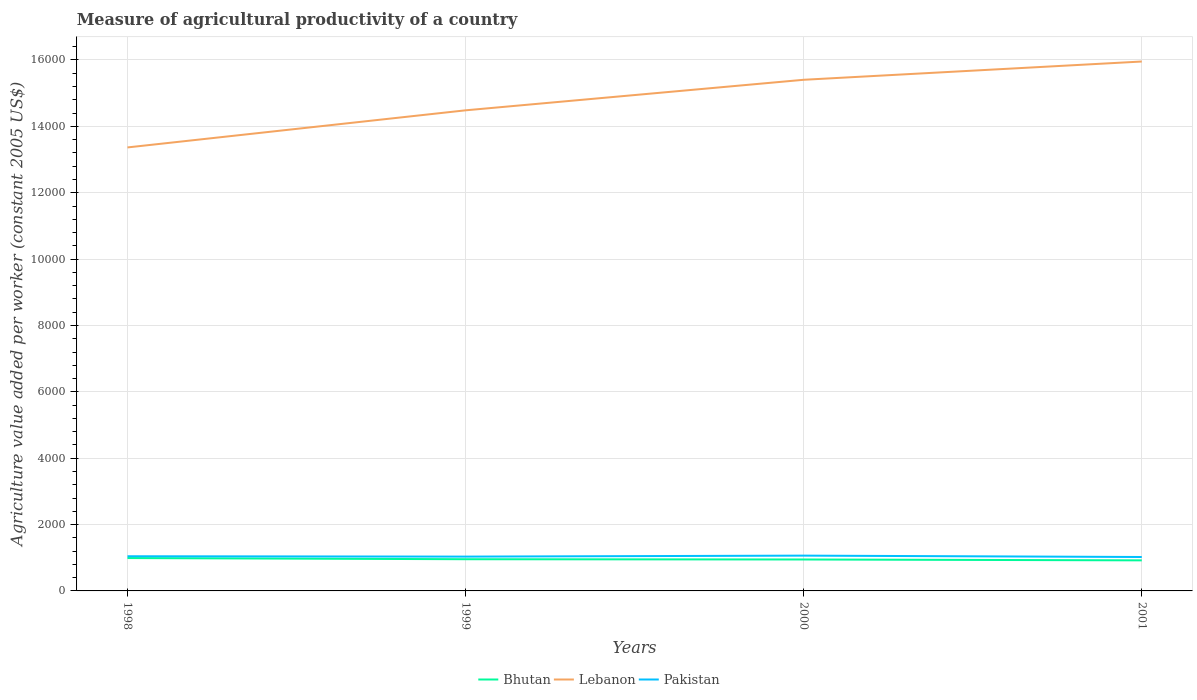How many different coloured lines are there?
Ensure brevity in your answer.  3. Does the line corresponding to Pakistan intersect with the line corresponding to Bhutan?
Offer a terse response. No. Is the number of lines equal to the number of legend labels?
Offer a terse response. Yes. Across all years, what is the maximum measure of agricultural productivity in Pakistan?
Make the answer very short. 1022.46. In which year was the measure of agricultural productivity in Pakistan maximum?
Keep it short and to the point. 2001. What is the total measure of agricultural productivity in Lebanon in the graph?
Give a very brief answer. -920.3. What is the difference between the highest and the second highest measure of agricultural productivity in Bhutan?
Make the answer very short. 69.25. How many lines are there?
Offer a very short reply. 3. How many legend labels are there?
Provide a short and direct response. 3. What is the title of the graph?
Offer a terse response. Measure of agricultural productivity of a country. What is the label or title of the Y-axis?
Offer a very short reply. Agriculture value added per worker (constant 2005 US$). What is the Agriculture value added per worker (constant 2005 US$) of Bhutan in 1998?
Your answer should be very brief. 990.49. What is the Agriculture value added per worker (constant 2005 US$) in Lebanon in 1998?
Offer a terse response. 1.34e+04. What is the Agriculture value added per worker (constant 2005 US$) of Pakistan in 1998?
Offer a very short reply. 1044.93. What is the Agriculture value added per worker (constant 2005 US$) of Bhutan in 1999?
Give a very brief answer. 955.44. What is the Agriculture value added per worker (constant 2005 US$) in Lebanon in 1999?
Keep it short and to the point. 1.45e+04. What is the Agriculture value added per worker (constant 2005 US$) in Pakistan in 1999?
Provide a succinct answer. 1034. What is the Agriculture value added per worker (constant 2005 US$) in Bhutan in 2000?
Keep it short and to the point. 947.3. What is the Agriculture value added per worker (constant 2005 US$) in Lebanon in 2000?
Your response must be concise. 1.54e+04. What is the Agriculture value added per worker (constant 2005 US$) of Pakistan in 2000?
Your response must be concise. 1063.71. What is the Agriculture value added per worker (constant 2005 US$) of Bhutan in 2001?
Provide a succinct answer. 921.23. What is the Agriculture value added per worker (constant 2005 US$) of Lebanon in 2001?
Your response must be concise. 1.60e+04. What is the Agriculture value added per worker (constant 2005 US$) in Pakistan in 2001?
Your answer should be compact. 1022.46. Across all years, what is the maximum Agriculture value added per worker (constant 2005 US$) in Bhutan?
Provide a succinct answer. 990.49. Across all years, what is the maximum Agriculture value added per worker (constant 2005 US$) of Lebanon?
Your answer should be very brief. 1.60e+04. Across all years, what is the maximum Agriculture value added per worker (constant 2005 US$) of Pakistan?
Your answer should be compact. 1063.71. Across all years, what is the minimum Agriculture value added per worker (constant 2005 US$) in Bhutan?
Ensure brevity in your answer.  921.23. Across all years, what is the minimum Agriculture value added per worker (constant 2005 US$) in Lebanon?
Your response must be concise. 1.34e+04. Across all years, what is the minimum Agriculture value added per worker (constant 2005 US$) of Pakistan?
Offer a terse response. 1022.46. What is the total Agriculture value added per worker (constant 2005 US$) in Bhutan in the graph?
Offer a very short reply. 3814.46. What is the total Agriculture value added per worker (constant 2005 US$) in Lebanon in the graph?
Your answer should be very brief. 5.92e+04. What is the total Agriculture value added per worker (constant 2005 US$) of Pakistan in the graph?
Your response must be concise. 4165.11. What is the difference between the Agriculture value added per worker (constant 2005 US$) in Bhutan in 1998 and that in 1999?
Your answer should be compact. 35.05. What is the difference between the Agriculture value added per worker (constant 2005 US$) of Lebanon in 1998 and that in 1999?
Give a very brief answer. -1118.39. What is the difference between the Agriculture value added per worker (constant 2005 US$) in Pakistan in 1998 and that in 1999?
Offer a very short reply. 10.93. What is the difference between the Agriculture value added per worker (constant 2005 US$) in Bhutan in 1998 and that in 2000?
Provide a succinct answer. 43.19. What is the difference between the Agriculture value added per worker (constant 2005 US$) of Lebanon in 1998 and that in 2000?
Give a very brief answer. -2038.69. What is the difference between the Agriculture value added per worker (constant 2005 US$) in Pakistan in 1998 and that in 2000?
Make the answer very short. -18.78. What is the difference between the Agriculture value added per worker (constant 2005 US$) in Bhutan in 1998 and that in 2001?
Ensure brevity in your answer.  69.25. What is the difference between the Agriculture value added per worker (constant 2005 US$) of Lebanon in 1998 and that in 2001?
Provide a succinct answer. -2589.12. What is the difference between the Agriculture value added per worker (constant 2005 US$) in Pakistan in 1998 and that in 2001?
Give a very brief answer. 22.47. What is the difference between the Agriculture value added per worker (constant 2005 US$) in Bhutan in 1999 and that in 2000?
Make the answer very short. 8.14. What is the difference between the Agriculture value added per worker (constant 2005 US$) in Lebanon in 1999 and that in 2000?
Ensure brevity in your answer.  -920.3. What is the difference between the Agriculture value added per worker (constant 2005 US$) in Pakistan in 1999 and that in 2000?
Provide a succinct answer. -29.71. What is the difference between the Agriculture value added per worker (constant 2005 US$) of Bhutan in 1999 and that in 2001?
Give a very brief answer. 34.2. What is the difference between the Agriculture value added per worker (constant 2005 US$) in Lebanon in 1999 and that in 2001?
Your answer should be very brief. -1470.73. What is the difference between the Agriculture value added per worker (constant 2005 US$) of Pakistan in 1999 and that in 2001?
Your answer should be compact. 11.54. What is the difference between the Agriculture value added per worker (constant 2005 US$) of Bhutan in 2000 and that in 2001?
Your answer should be compact. 26.06. What is the difference between the Agriculture value added per worker (constant 2005 US$) of Lebanon in 2000 and that in 2001?
Provide a succinct answer. -550.43. What is the difference between the Agriculture value added per worker (constant 2005 US$) of Pakistan in 2000 and that in 2001?
Your answer should be compact. 41.25. What is the difference between the Agriculture value added per worker (constant 2005 US$) in Bhutan in 1998 and the Agriculture value added per worker (constant 2005 US$) in Lebanon in 1999?
Your response must be concise. -1.35e+04. What is the difference between the Agriculture value added per worker (constant 2005 US$) of Bhutan in 1998 and the Agriculture value added per worker (constant 2005 US$) of Pakistan in 1999?
Ensure brevity in your answer.  -43.51. What is the difference between the Agriculture value added per worker (constant 2005 US$) in Lebanon in 1998 and the Agriculture value added per worker (constant 2005 US$) in Pakistan in 1999?
Ensure brevity in your answer.  1.23e+04. What is the difference between the Agriculture value added per worker (constant 2005 US$) of Bhutan in 1998 and the Agriculture value added per worker (constant 2005 US$) of Lebanon in 2000?
Keep it short and to the point. -1.44e+04. What is the difference between the Agriculture value added per worker (constant 2005 US$) in Bhutan in 1998 and the Agriculture value added per worker (constant 2005 US$) in Pakistan in 2000?
Keep it short and to the point. -73.22. What is the difference between the Agriculture value added per worker (constant 2005 US$) of Lebanon in 1998 and the Agriculture value added per worker (constant 2005 US$) of Pakistan in 2000?
Offer a terse response. 1.23e+04. What is the difference between the Agriculture value added per worker (constant 2005 US$) in Bhutan in 1998 and the Agriculture value added per worker (constant 2005 US$) in Lebanon in 2001?
Provide a succinct answer. -1.50e+04. What is the difference between the Agriculture value added per worker (constant 2005 US$) in Bhutan in 1998 and the Agriculture value added per worker (constant 2005 US$) in Pakistan in 2001?
Your answer should be very brief. -31.98. What is the difference between the Agriculture value added per worker (constant 2005 US$) of Lebanon in 1998 and the Agriculture value added per worker (constant 2005 US$) of Pakistan in 2001?
Your response must be concise. 1.23e+04. What is the difference between the Agriculture value added per worker (constant 2005 US$) in Bhutan in 1999 and the Agriculture value added per worker (constant 2005 US$) in Lebanon in 2000?
Give a very brief answer. -1.44e+04. What is the difference between the Agriculture value added per worker (constant 2005 US$) of Bhutan in 1999 and the Agriculture value added per worker (constant 2005 US$) of Pakistan in 2000?
Your response must be concise. -108.27. What is the difference between the Agriculture value added per worker (constant 2005 US$) of Lebanon in 1999 and the Agriculture value added per worker (constant 2005 US$) of Pakistan in 2000?
Offer a terse response. 1.34e+04. What is the difference between the Agriculture value added per worker (constant 2005 US$) in Bhutan in 1999 and the Agriculture value added per worker (constant 2005 US$) in Lebanon in 2001?
Provide a succinct answer. -1.50e+04. What is the difference between the Agriculture value added per worker (constant 2005 US$) of Bhutan in 1999 and the Agriculture value added per worker (constant 2005 US$) of Pakistan in 2001?
Your response must be concise. -67.03. What is the difference between the Agriculture value added per worker (constant 2005 US$) in Lebanon in 1999 and the Agriculture value added per worker (constant 2005 US$) in Pakistan in 2001?
Your response must be concise. 1.35e+04. What is the difference between the Agriculture value added per worker (constant 2005 US$) of Bhutan in 2000 and the Agriculture value added per worker (constant 2005 US$) of Lebanon in 2001?
Provide a short and direct response. -1.50e+04. What is the difference between the Agriculture value added per worker (constant 2005 US$) of Bhutan in 2000 and the Agriculture value added per worker (constant 2005 US$) of Pakistan in 2001?
Offer a terse response. -75.17. What is the difference between the Agriculture value added per worker (constant 2005 US$) of Lebanon in 2000 and the Agriculture value added per worker (constant 2005 US$) of Pakistan in 2001?
Your answer should be very brief. 1.44e+04. What is the average Agriculture value added per worker (constant 2005 US$) in Bhutan per year?
Keep it short and to the point. 953.61. What is the average Agriculture value added per worker (constant 2005 US$) in Lebanon per year?
Offer a terse response. 1.48e+04. What is the average Agriculture value added per worker (constant 2005 US$) of Pakistan per year?
Ensure brevity in your answer.  1041.28. In the year 1998, what is the difference between the Agriculture value added per worker (constant 2005 US$) of Bhutan and Agriculture value added per worker (constant 2005 US$) of Lebanon?
Your answer should be very brief. -1.24e+04. In the year 1998, what is the difference between the Agriculture value added per worker (constant 2005 US$) of Bhutan and Agriculture value added per worker (constant 2005 US$) of Pakistan?
Make the answer very short. -54.45. In the year 1998, what is the difference between the Agriculture value added per worker (constant 2005 US$) of Lebanon and Agriculture value added per worker (constant 2005 US$) of Pakistan?
Offer a terse response. 1.23e+04. In the year 1999, what is the difference between the Agriculture value added per worker (constant 2005 US$) in Bhutan and Agriculture value added per worker (constant 2005 US$) in Lebanon?
Give a very brief answer. -1.35e+04. In the year 1999, what is the difference between the Agriculture value added per worker (constant 2005 US$) of Bhutan and Agriculture value added per worker (constant 2005 US$) of Pakistan?
Your answer should be compact. -78.56. In the year 1999, what is the difference between the Agriculture value added per worker (constant 2005 US$) in Lebanon and Agriculture value added per worker (constant 2005 US$) in Pakistan?
Give a very brief answer. 1.34e+04. In the year 2000, what is the difference between the Agriculture value added per worker (constant 2005 US$) in Bhutan and Agriculture value added per worker (constant 2005 US$) in Lebanon?
Provide a short and direct response. -1.45e+04. In the year 2000, what is the difference between the Agriculture value added per worker (constant 2005 US$) in Bhutan and Agriculture value added per worker (constant 2005 US$) in Pakistan?
Your answer should be very brief. -116.41. In the year 2000, what is the difference between the Agriculture value added per worker (constant 2005 US$) of Lebanon and Agriculture value added per worker (constant 2005 US$) of Pakistan?
Make the answer very short. 1.43e+04. In the year 2001, what is the difference between the Agriculture value added per worker (constant 2005 US$) in Bhutan and Agriculture value added per worker (constant 2005 US$) in Lebanon?
Keep it short and to the point. -1.50e+04. In the year 2001, what is the difference between the Agriculture value added per worker (constant 2005 US$) in Bhutan and Agriculture value added per worker (constant 2005 US$) in Pakistan?
Your answer should be very brief. -101.23. In the year 2001, what is the difference between the Agriculture value added per worker (constant 2005 US$) of Lebanon and Agriculture value added per worker (constant 2005 US$) of Pakistan?
Ensure brevity in your answer.  1.49e+04. What is the ratio of the Agriculture value added per worker (constant 2005 US$) of Bhutan in 1998 to that in 1999?
Your answer should be compact. 1.04. What is the ratio of the Agriculture value added per worker (constant 2005 US$) of Lebanon in 1998 to that in 1999?
Your answer should be compact. 0.92. What is the ratio of the Agriculture value added per worker (constant 2005 US$) of Pakistan in 1998 to that in 1999?
Make the answer very short. 1.01. What is the ratio of the Agriculture value added per worker (constant 2005 US$) of Bhutan in 1998 to that in 2000?
Make the answer very short. 1.05. What is the ratio of the Agriculture value added per worker (constant 2005 US$) in Lebanon in 1998 to that in 2000?
Your response must be concise. 0.87. What is the ratio of the Agriculture value added per worker (constant 2005 US$) in Pakistan in 1998 to that in 2000?
Your response must be concise. 0.98. What is the ratio of the Agriculture value added per worker (constant 2005 US$) in Bhutan in 1998 to that in 2001?
Ensure brevity in your answer.  1.08. What is the ratio of the Agriculture value added per worker (constant 2005 US$) in Lebanon in 1998 to that in 2001?
Provide a short and direct response. 0.84. What is the ratio of the Agriculture value added per worker (constant 2005 US$) in Pakistan in 1998 to that in 2001?
Provide a succinct answer. 1.02. What is the ratio of the Agriculture value added per worker (constant 2005 US$) in Bhutan in 1999 to that in 2000?
Ensure brevity in your answer.  1.01. What is the ratio of the Agriculture value added per worker (constant 2005 US$) in Lebanon in 1999 to that in 2000?
Provide a short and direct response. 0.94. What is the ratio of the Agriculture value added per worker (constant 2005 US$) of Pakistan in 1999 to that in 2000?
Provide a succinct answer. 0.97. What is the ratio of the Agriculture value added per worker (constant 2005 US$) in Bhutan in 1999 to that in 2001?
Make the answer very short. 1.04. What is the ratio of the Agriculture value added per worker (constant 2005 US$) of Lebanon in 1999 to that in 2001?
Ensure brevity in your answer.  0.91. What is the ratio of the Agriculture value added per worker (constant 2005 US$) in Pakistan in 1999 to that in 2001?
Give a very brief answer. 1.01. What is the ratio of the Agriculture value added per worker (constant 2005 US$) of Bhutan in 2000 to that in 2001?
Offer a terse response. 1.03. What is the ratio of the Agriculture value added per worker (constant 2005 US$) in Lebanon in 2000 to that in 2001?
Your response must be concise. 0.97. What is the ratio of the Agriculture value added per worker (constant 2005 US$) in Pakistan in 2000 to that in 2001?
Offer a very short reply. 1.04. What is the difference between the highest and the second highest Agriculture value added per worker (constant 2005 US$) in Bhutan?
Provide a short and direct response. 35.05. What is the difference between the highest and the second highest Agriculture value added per worker (constant 2005 US$) of Lebanon?
Offer a terse response. 550.43. What is the difference between the highest and the second highest Agriculture value added per worker (constant 2005 US$) of Pakistan?
Offer a very short reply. 18.78. What is the difference between the highest and the lowest Agriculture value added per worker (constant 2005 US$) in Bhutan?
Make the answer very short. 69.25. What is the difference between the highest and the lowest Agriculture value added per worker (constant 2005 US$) in Lebanon?
Provide a succinct answer. 2589.12. What is the difference between the highest and the lowest Agriculture value added per worker (constant 2005 US$) in Pakistan?
Your answer should be very brief. 41.25. 